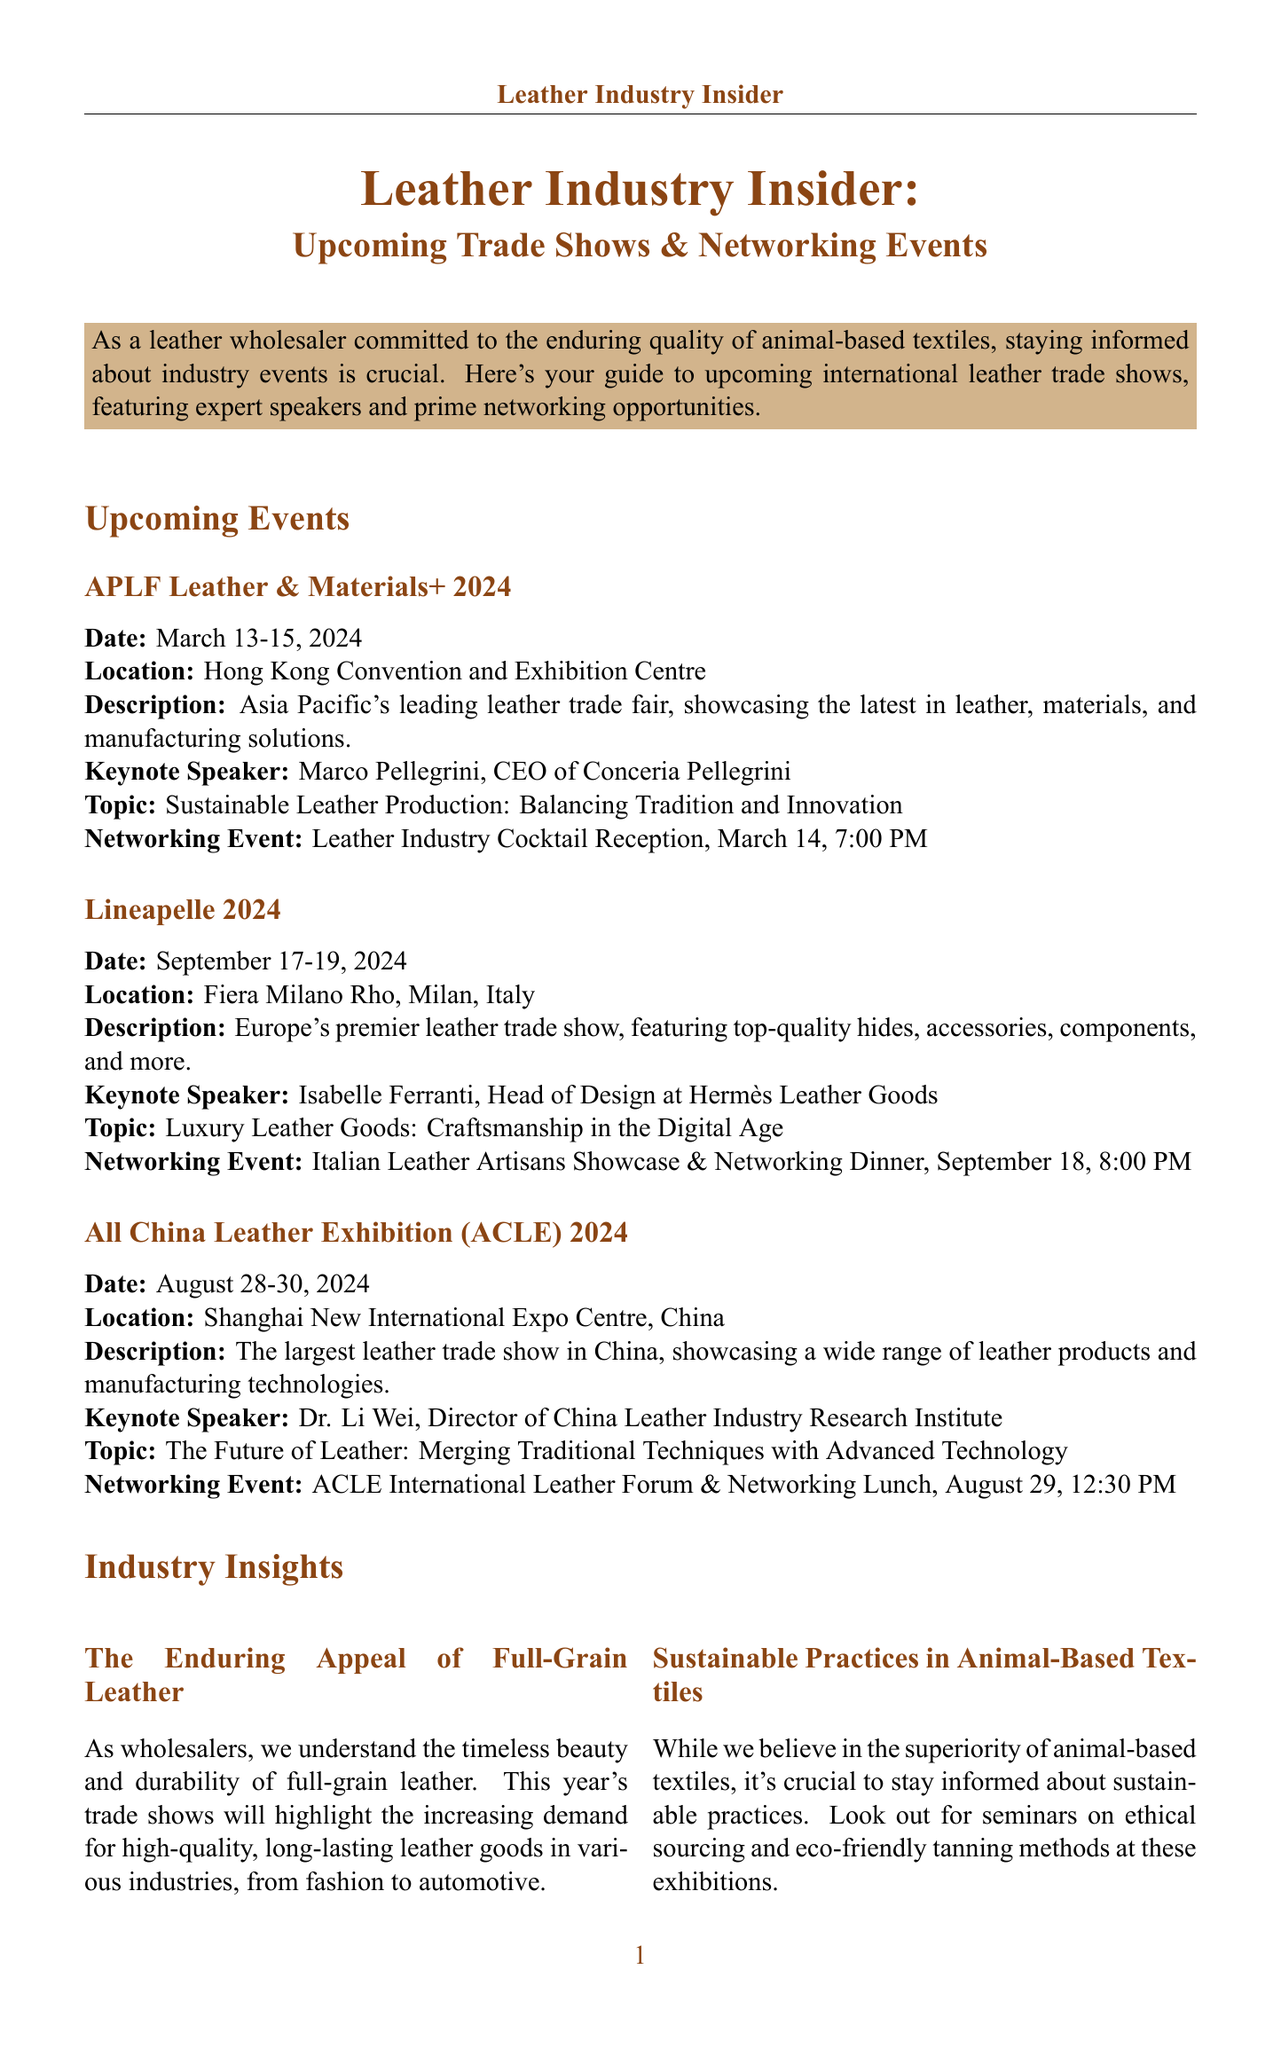What are the dates for APLF Leather & Materials+ 2024? The dates for APLF Leather & Materials+ 2024 are listed in the document as March 13-15, 2024.
Answer: March 13-15, 2024 Who is the keynote speaker at Lineapelle 2024? The document mentions that the keynote speaker at Lineapelle 2024 is Isabelle Ferranti.
Answer: Isabelle Ferranti What is the main topic of Dr. Li Wei's presentation? The document describes the topic of Dr. Li Wei's presentation as "The Future of Leather: Merging Traditional Techniques with Advanced Technology."
Answer: The Future of Leather: Merging Traditional Techniques with Advanced Technology What networking event is scheduled for APLF Leather & Materials+ 2024? The document indicates that there is a networking event called "Leather Industry Cocktail Reception" scheduled for March 14, 7:00 PM.
Answer: Leather Industry Cocktail Reception, March 14, 7:00 PM How many industry insights are provided in the document? The document lists three industry insights, which can be counted from the respective section.
Answer: Three What is highlighted in the event descriptions regarding the leather trade shows? The descriptions emphasize the showcasing of latest innovations and products in the leather industry during the trade shows.
Answer: Showcasing the latest in leather, materials, and manufacturing solutions What time is the networking lunch at the All China Leather Exhibition? The document states that the networking lunch is scheduled for August 29, 12:30 PM.
Answer: August 29, 12:30 PM What should attendees prepare before the networking events according to the tips? The document advises attendees to prepare a brief pitch highlighting their commitment to quality and traditional leather craftsmanship.
Answer: Prepare a brief pitch highlighting your commitment to quality and traditional leather craftsmanship 